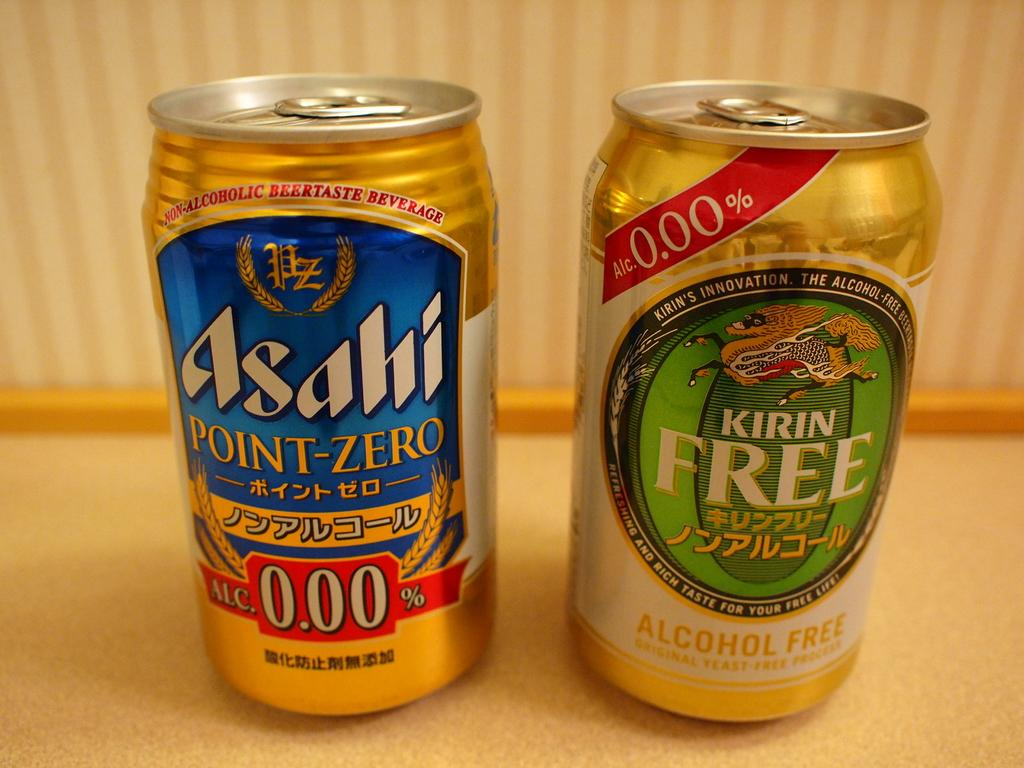<image>
Give a short and clear explanation of the subsequent image. A can of Asahi point-zero sits next to a can of Kirin Free. 